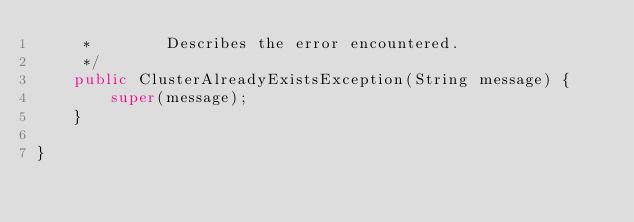Convert code to text. <code><loc_0><loc_0><loc_500><loc_500><_Java_>     *        Describes the error encountered.
     */
    public ClusterAlreadyExistsException(String message) {
        super(message);
    }

}
</code> 